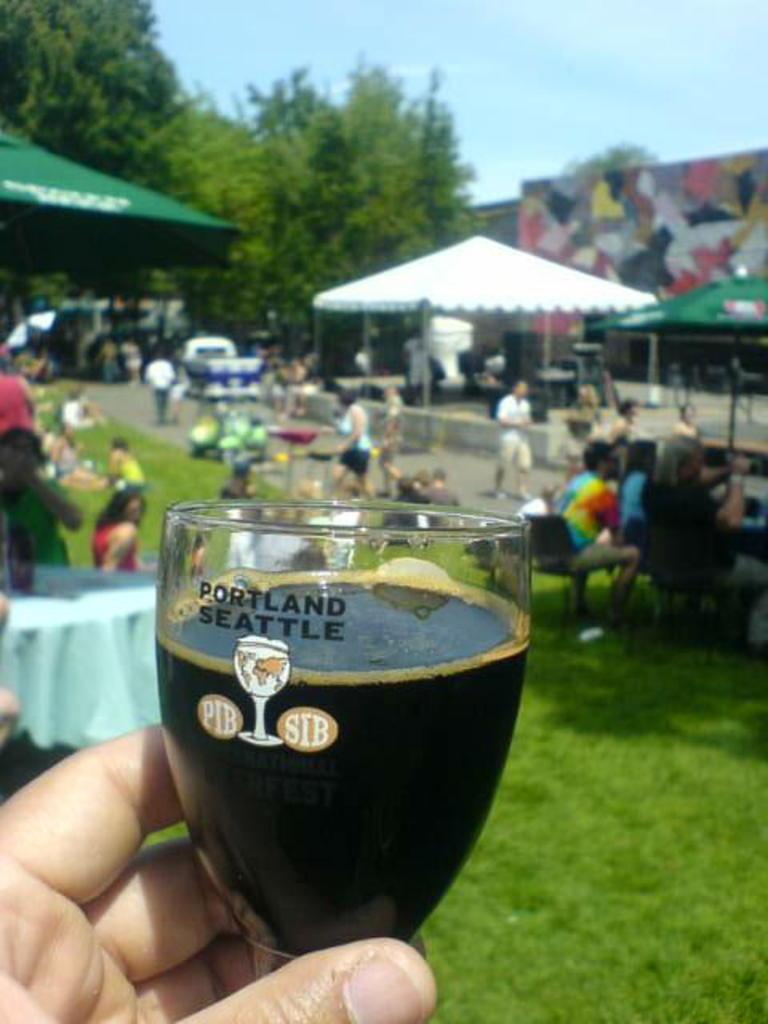What acronyms are on the glass?
Give a very brief answer. Pib sib. 